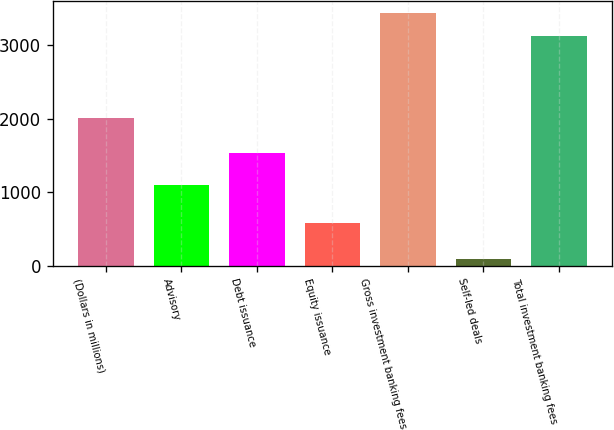Convert chart. <chart><loc_0><loc_0><loc_500><loc_500><bar_chart><fcel>(Dollars in millions)<fcel>Advisory<fcel>Debt issuance<fcel>Equity issuance<fcel>Gross investment banking fees<fcel>Self-led deals<fcel>Total investment banking fees<nl><fcel>2014<fcel>1098<fcel>1532<fcel>583<fcel>3434.2<fcel>91<fcel>3122<nl></chart> 